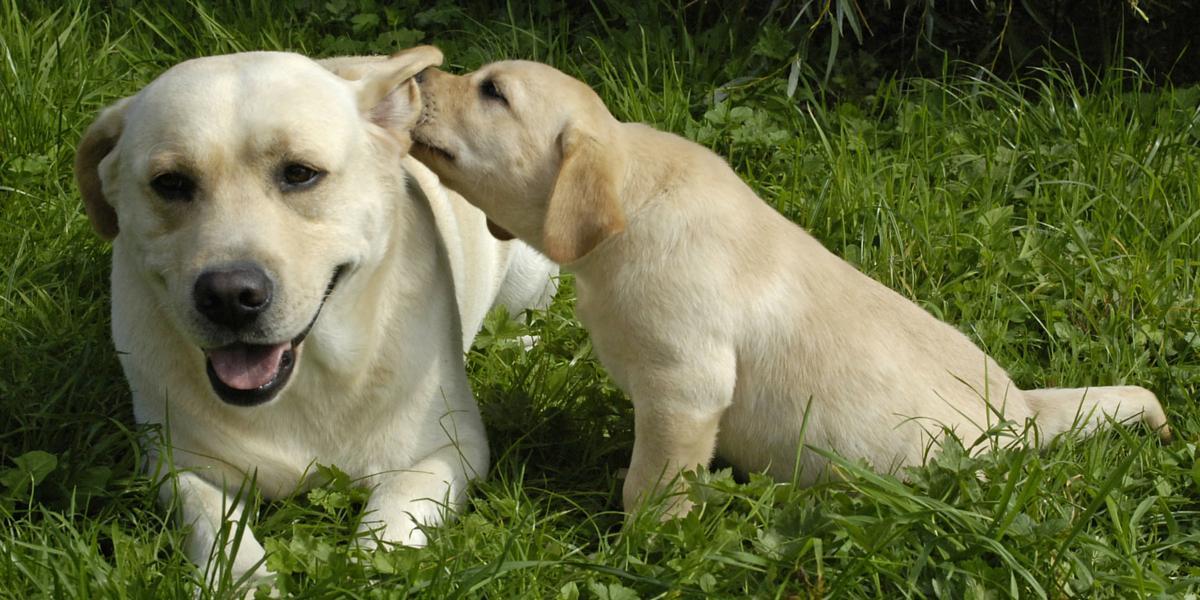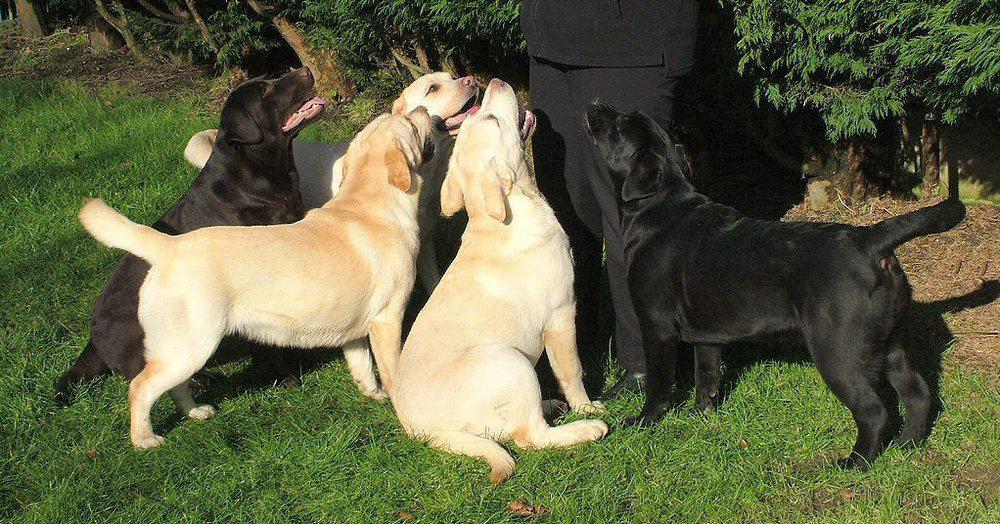The first image is the image on the left, the second image is the image on the right. Examine the images to the left and right. Is the description "In one of the images there are exactly two golden labs interacting with each other." accurate? Answer yes or no. Yes. The first image is the image on the left, the second image is the image on the right. Examine the images to the left and right. Is the description "One image features exactly two dogs relaxing on the grass." accurate? Answer yes or no. Yes. 